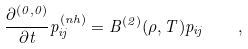<formula> <loc_0><loc_0><loc_500><loc_500>\frac { \partial ^ { ( 0 , 0 ) } } { \partial t } p _ { i j } ^ { ( n h ) } = B ^ { ( 2 ) } ( \rho , T ) p _ { i j } \quad ,</formula> 